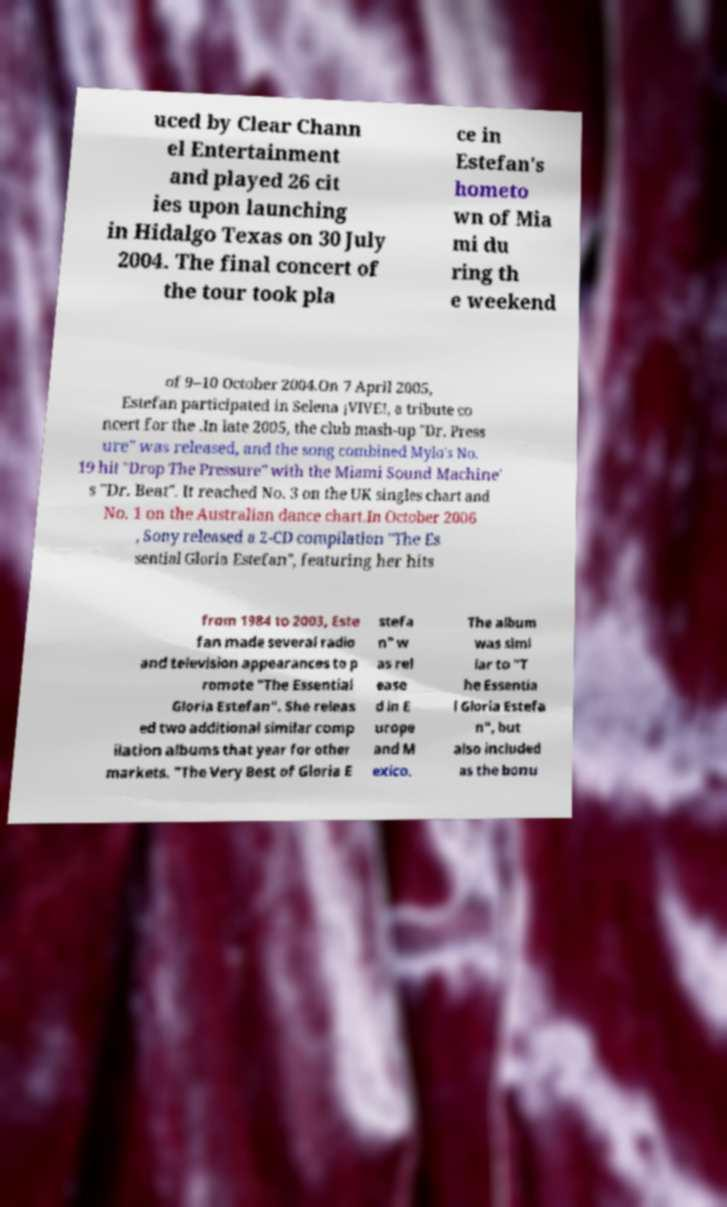I need the written content from this picture converted into text. Can you do that? uced by Clear Chann el Entertainment and played 26 cit ies upon launching in Hidalgo Texas on 30 July 2004. The final concert of the tour took pla ce in Estefan's hometo wn of Mia mi du ring th e weekend of 9–10 October 2004.On 7 April 2005, Estefan participated in Selena ¡VIVE!, a tribute co ncert for the .In late 2005, the club mash-up "Dr. Press ure" was released, and the song combined Mylo's No. 19 hit "Drop The Pressure" with the Miami Sound Machine' s "Dr. Beat". It reached No. 3 on the UK singles chart and No. 1 on the Australian dance chart.In October 2006 , Sony released a 2-CD compilation "The Es sential Gloria Estefan", featuring her hits from 1984 to 2003, Este fan made several radio and television appearances to p romote "The Essential Gloria Estefan". She releas ed two additional similar comp ilation albums that year for other markets. "The Very Best of Gloria E stefa n" w as rel ease d in E urope and M exico. The album was simi lar to "T he Essentia l Gloria Estefa n", but also included as the bonu 